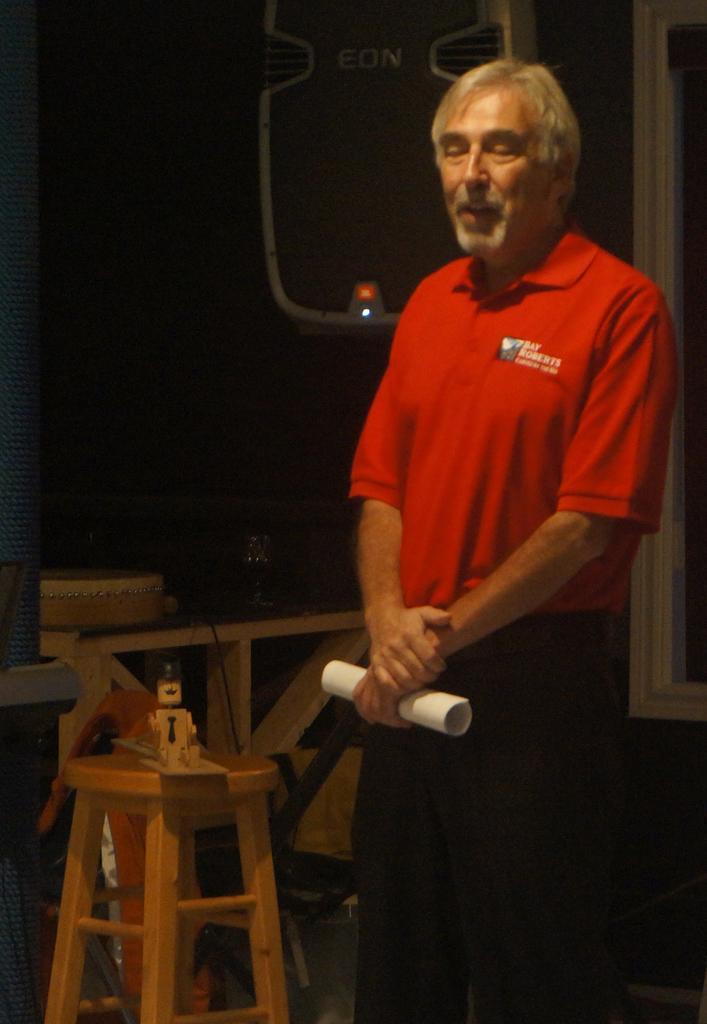Can you describe this image briefly? On the right side of the image we can see person standing and holding a paper. On the left side of the image we can see you on the stool. In the background we can see air conditioner, window and wall. 